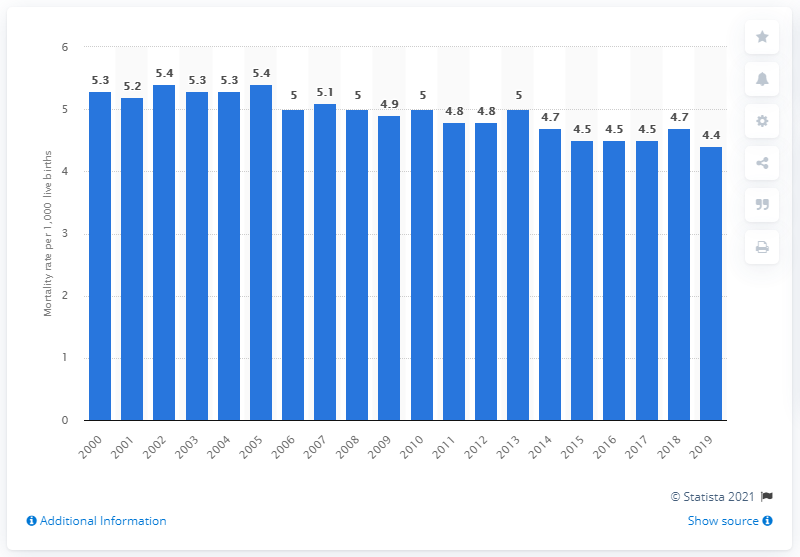Point out several critical features in this image. In 2019, the number of infant deaths per 1,000 live births in Canada was 4.4. 